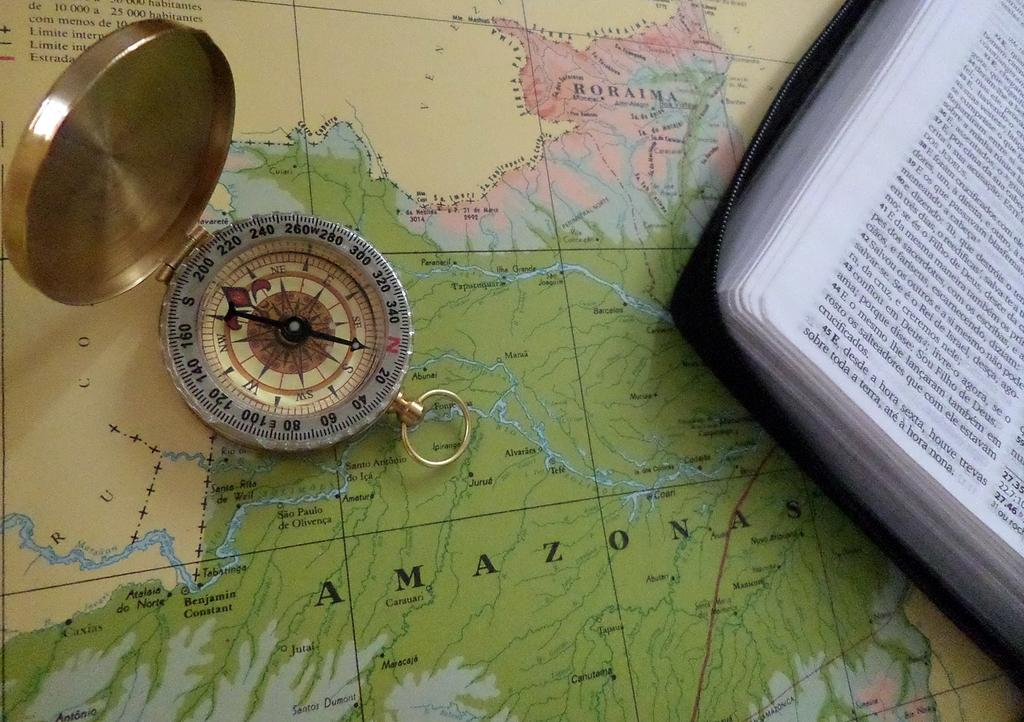What is the main object in the image? There is a map in the image. What other objects can be seen in the image? There is a book and a compass in the image. How many strings are attached to the map in the image? There are no strings attached to the map in the image. Are there any scissors visible in the image? There is no mention of scissors in the provided facts, and therefore we cannot determine if they are present in the image. 